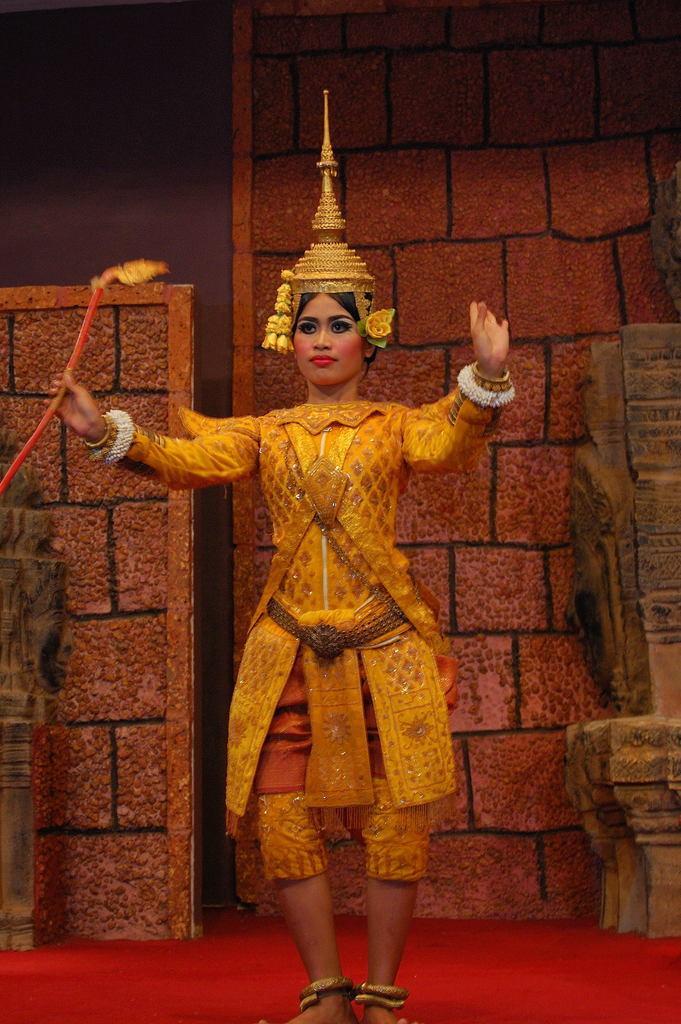In one or two sentences, can you explain what this image depicts? In the image there is a woman in traditional costume and crown over head dancing on red floor with a wall behind her. 